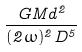<formula> <loc_0><loc_0><loc_500><loc_500>\frac { G M d ^ { 2 } } { ( 2 \omega ) ^ { 2 } D ^ { 5 } }</formula> 